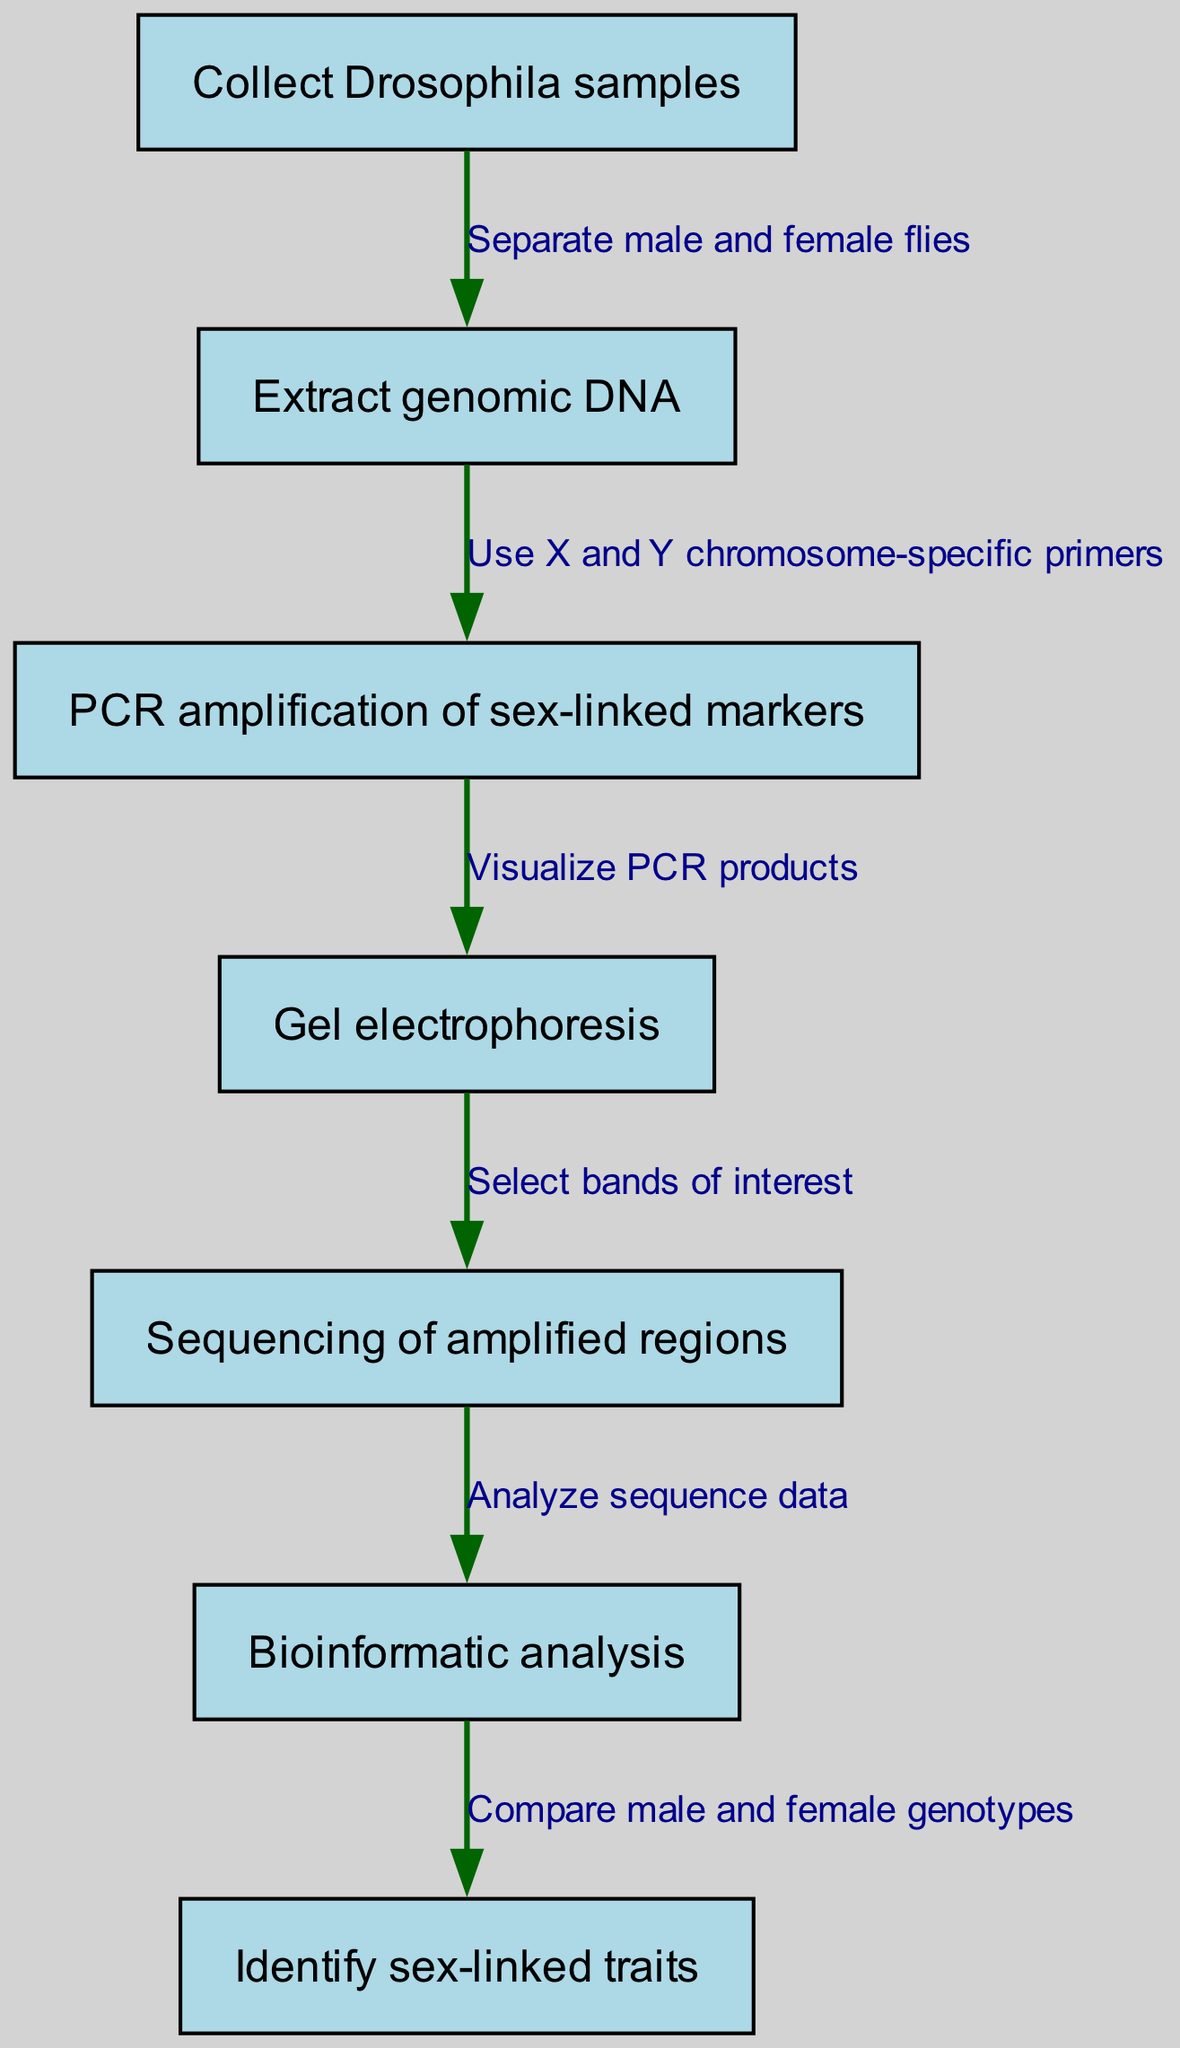What is the first step in the genetic screening process? The diagram indicates "Collect Drosophila samples" as the first step, which is depicted as node 1.
Answer: Collect Drosophila samples How many total nodes are presented in the diagram? Counting the nodes listed in the diagram, there are a total of 7 nodes representing each step in the genetic screening process.
Answer: 7 What follows the extraction of genomic DNA? After "Extract genomic DNA," the next step is "PCR amplification of sex-linked markers," which is indicated by the edge from node 2 to node 3.
Answer: PCR amplification of sex-linked markers Which step involves visualizing PCR products? The step that involves visualizing PCR products is "Gel electrophoresis," which is node 4 in the diagram.
Answer: Gel electrophoresis What is the final outcome of the genetic screening process? According to the diagram, the final outcome of the genetic screening process is "Identify sex-linked traits," represented by node 7.
Answer: Identify sex-linked traits What is the connection between PCR amplification and gel electrophoresis? The connection is that from "PCR amplification of sex-linked markers" (node 3), the process proceeds to "Gel electrophoresis" (node 4), as represented by the directed edge showing the stepwise flow of the process.
Answer: Visualize PCR products How many edges are involved in the process? The diagram specifies that there are a total of 6 edges connecting the nodes, indicating the relationships and flow between the steps.
Answer: 6 What specific primers are used during the amplification step? The amplification step specifically uses "X and Y chromosome-specific primers" as indicated in the edge text from node 2 to node 3.
Answer: X and Y chromosome-specific primers What analysis is performed after sequencing? Following "Sequencing of amplified regions," the next step is "Bioinformatic analysis," which indicates the analysis done on the sequence data obtained.
Answer: Bioinformatic analysis 